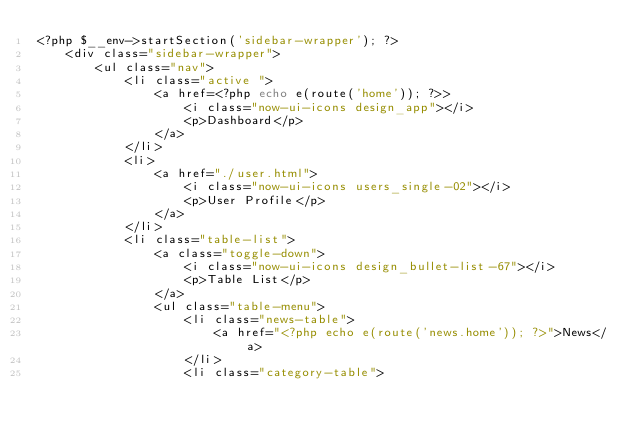Convert code to text. <code><loc_0><loc_0><loc_500><loc_500><_PHP_><?php $__env->startSection('sidebar-wrapper'); ?>
    <div class="sidebar-wrapper">
        <ul class="nav">
            <li class="active ">
                <a href=<?php echo e(route('home')); ?>>
                    <i class="now-ui-icons design_app"></i>
                    <p>Dashboard</p>
                </a>
            </li>
            <li>
                <a href="./user.html">
                    <i class="now-ui-icons users_single-02"></i>
                    <p>User Profile</p>
                </a>
            </li>
            <li class="table-list">
                <a class="toggle-down">
                    <i class="now-ui-icons design_bullet-list-67"></i>
                    <p>Table List</p>
                </a>
                <ul class="table-menu">
                    <li class="news-table">
                        <a href="<?php echo e(route('news.home')); ?>">News</a>
                    </li>
                    <li class="category-table"></code> 